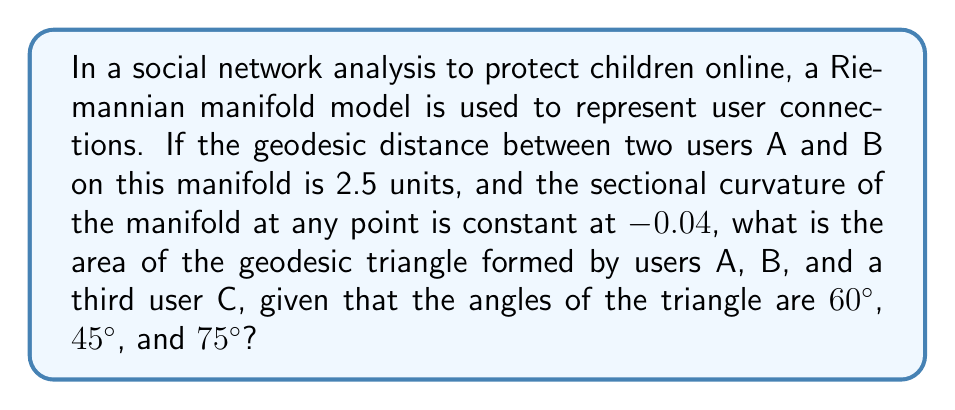Solve this math problem. To solve this problem, we'll use the Gauss-Bonnet theorem for hyperbolic geometry, as the negative curvature indicates a hyperbolic space. The steps are as follows:

1) The Gauss-Bonnet theorem for a geodesic triangle on a surface with constant curvature K is:

   $$A = (\alpha + \beta + \gamma - \pi) / K$$

   where A is the area, and α, β, γ are the angles of the triangle.

2) Convert the given angles to radians:
   60° = $\pi/3$
   45° = $\pi/4$
   75° = $5\pi/12$

3) Sum the angles:
   $$(\pi/3 + \pi/4 + 5\pi/12) - \pi = 11\pi/12 - \pi = -\pi/12$$

4) The curvature K is given as -0.04

5) Substitute into the formula:
   $$A = (-\pi/12) / (-0.04) = \pi/12 * 25 = 25\pi/12$$

6) Simplify:
   $$A \approx 6.54 \text{ square units}$$

Note that the given geodesic distance between A and B (2.5 units) wasn't needed for this calculation, as the Gauss-Bonnet theorem only requires the angles and curvature.
Answer: $$A = 25\pi/12 \approx 6.54 \text{ square units}$$ 